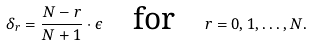<formula> <loc_0><loc_0><loc_500><loc_500>\delta _ { r } = \frac { N - r } { N + 1 } \cdot \epsilon \quad \text {for} \quad r = 0 , 1 , \dots , N .</formula> 